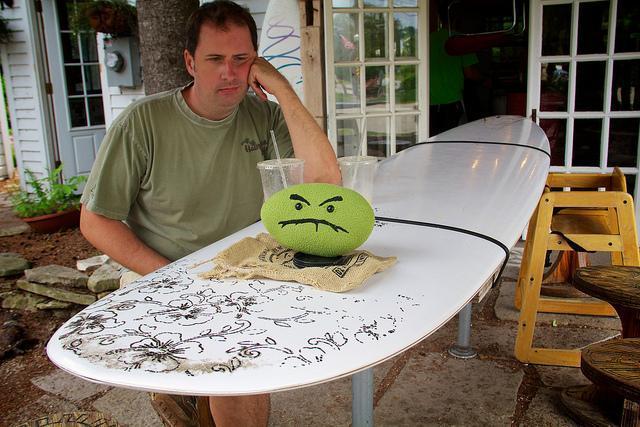How many people are in the picture?
Give a very brief answer. 2. 